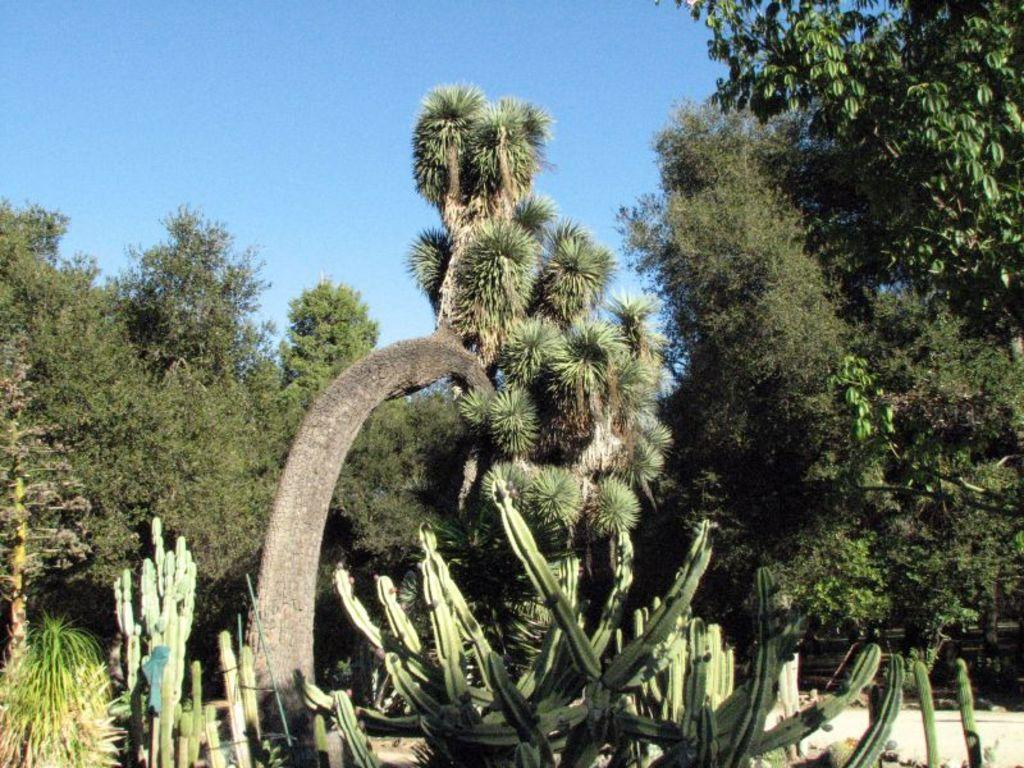What types of vegetation can be seen in the image? There are many plants and trees in the image. Where are the plants and trees located? The plants and trees are on land in the image. What part of the natural environment is visible in the image? The sky is visible in the image. What type of writer can be seen in the image? There is no writer present in the image; it features plants and trees on land with the sky visible. 